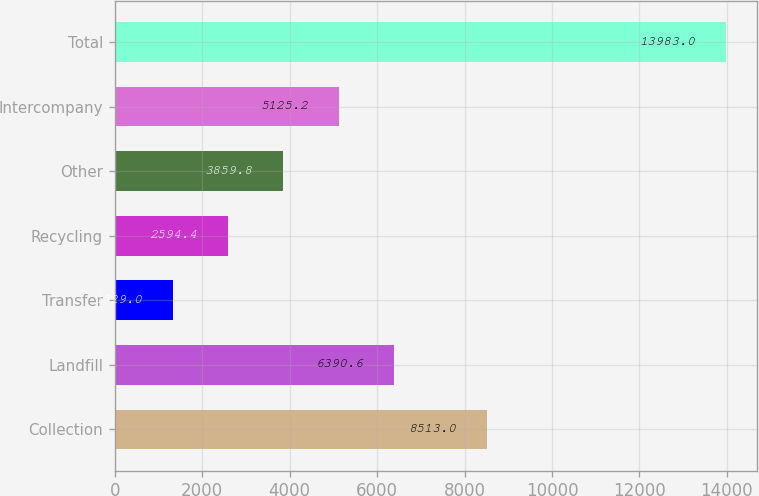Convert chart to OTSL. <chart><loc_0><loc_0><loc_500><loc_500><bar_chart><fcel>Collection<fcel>Landfill<fcel>Transfer<fcel>Recycling<fcel>Other<fcel>Intercompany<fcel>Total<nl><fcel>8513<fcel>6390.6<fcel>1329<fcel>2594.4<fcel>3859.8<fcel>5125.2<fcel>13983<nl></chart> 